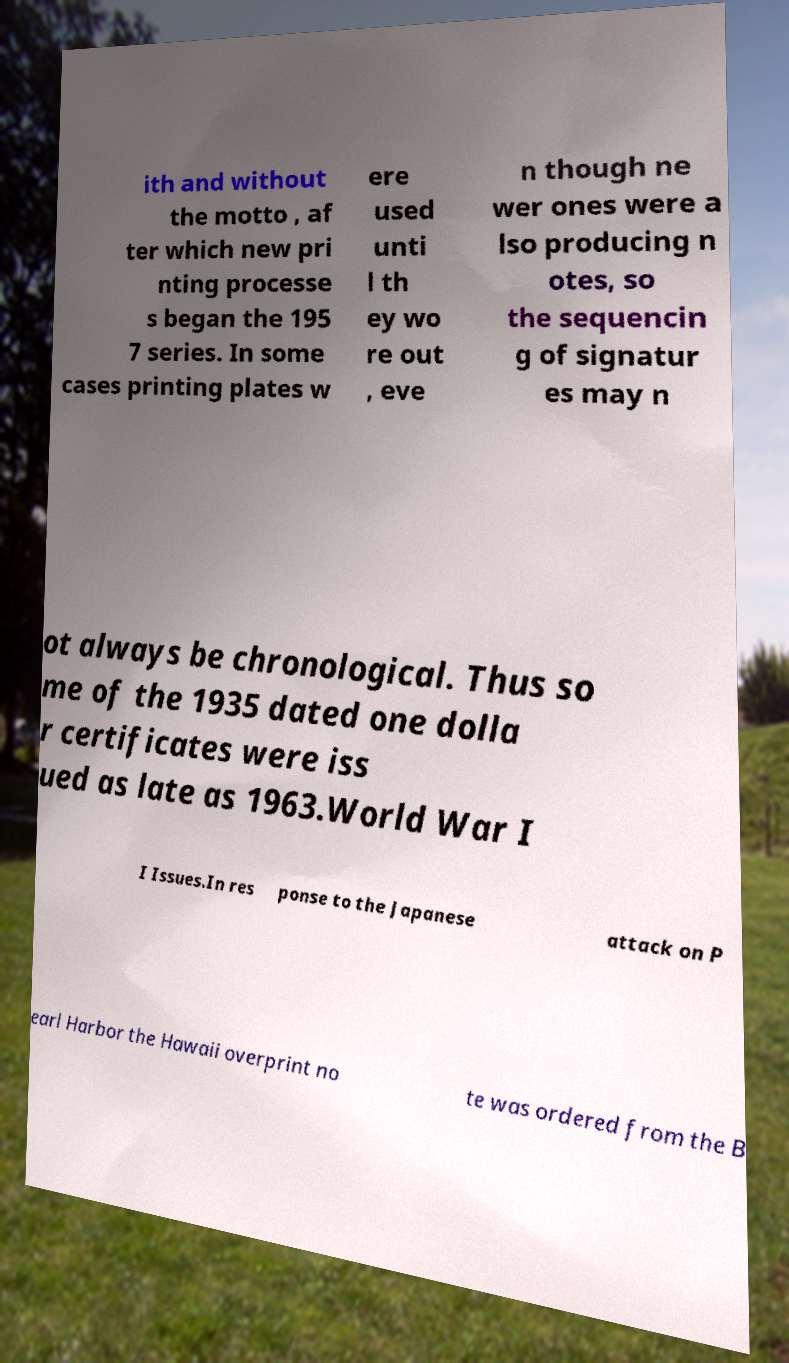What messages or text are displayed in this image? I need them in a readable, typed format. ith and without the motto , af ter which new pri nting processe s began the 195 7 series. In some cases printing plates w ere used unti l th ey wo re out , eve n though ne wer ones were a lso producing n otes, so the sequencin g of signatur es may n ot always be chronological. Thus so me of the 1935 dated one dolla r certificates were iss ued as late as 1963.World War I I Issues.In res ponse to the Japanese attack on P earl Harbor the Hawaii overprint no te was ordered from the B 